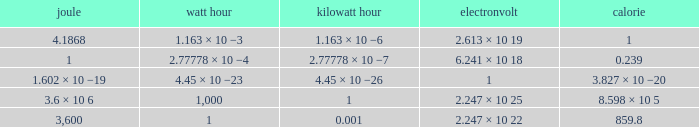How many electronvolts is 3,600 joules? 2.247 × 10 22. 